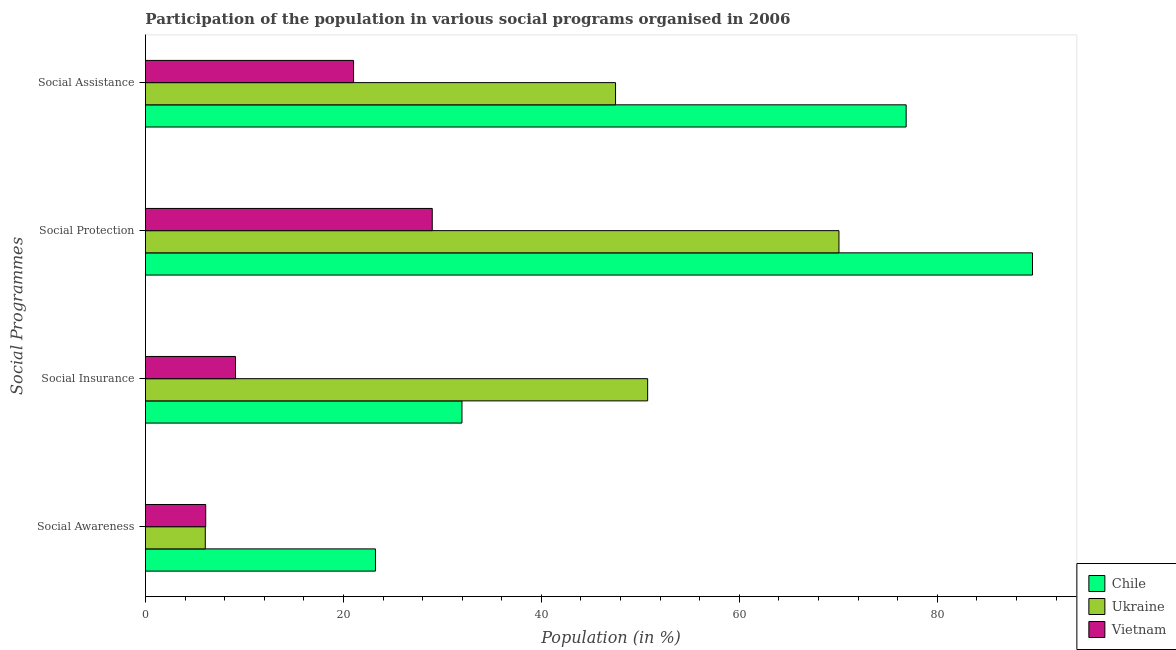How many groups of bars are there?
Provide a short and direct response. 4. What is the label of the 2nd group of bars from the top?
Your answer should be very brief. Social Protection. What is the participation of population in social awareness programs in Vietnam?
Make the answer very short. 6.09. Across all countries, what is the maximum participation of population in social assistance programs?
Give a very brief answer. 76.86. Across all countries, what is the minimum participation of population in social insurance programs?
Your answer should be compact. 9.1. In which country was the participation of population in social protection programs maximum?
Your response must be concise. Chile. In which country was the participation of population in social awareness programs minimum?
Give a very brief answer. Ukraine. What is the total participation of population in social assistance programs in the graph?
Offer a very short reply. 145.38. What is the difference between the participation of population in social insurance programs in Ukraine and that in Vietnam?
Provide a succinct answer. 41.64. What is the difference between the participation of population in social insurance programs in Chile and the participation of population in social assistance programs in Ukraine?
Provide a short and direct response. -15.52. What is the average participation of population in social protection programs per country?
Offer a terse response. 62.89. What is the difference between the participation of population in social assistance programs and participation of population in social insurance programs in Vietnam?
Ensure brevity in your answer.  11.93. What is the ratio of the participation of population in social awareness programs in Chile to that in Ukraine?
Make the answer very short. 3.84. Is the participation of population in social awareness programs in Chile less than that in Ukraine?
Provide a succinct answer. No. What is the difference between the highest and the second highest participation of population in social awareness programs?
Your response must be concise. 17.15. What is the difference between the highest and the lowest participation of population in social protection programs?
Provide a short and direct response. 60.64. Is it the case that in every country, the sum of the participation of population in social protection programs and participation of population in social insurance programs is greater than the sum of participation of population in social assistance programs and participation of population in social awareness programs?
Ensure brevity in your answer.  No. What does the 2nd bar from the top in Social Protection represents?
Keep it short and to the point. Ukraine. What does the 3rd bar from the bottom in Social Assistance represents?
Provide a succinct answer. Vietnam. How many countries are there in the graph?
Your answer should be very brief. 3. What is the difference between two consecutive major ticks on the X-axis?
Provide a short and direct response. 20. How many legend labels are there?
Make the answer very short. 3. What is the title of the graph?
Your answer should be compact. Participation of the population in various social programs organised in 2006. Does "Israel" appear as one of the legend labels in the graph?
Keep it short and to the point. No. What is the label or title of the X-axis?
Ensure brevity in your answer.  Population (in %). What is the label or title of the Y-axis?
Offer a very short reply. Social Programmes. What is the Population (in %) in Chile in Social Awareness?
Provide a succinct answer. 23.24. What is the Population (in %) of Ukraine in Social Awareness?
Offer a very short reply. 6.04. What is the Population (in %) of Vietnam in Social Awareness?
Your answer should be very brief. 6.09. What is the Population (in %) of Chile in Social Insurance?
Your response must be concise. 31.98. What is the Population (in %) of Ukraine in Social Insurance?
Your answer should be compact. 50.74. What is the Population (in %) in Vietnam in Social Insurance?
Keep it short and to the point. 9.1. What is the Population (in %) of Chile in Social Protection?
Provide a succinct answer. 89.62. What is the Population (in %) of Ukraine in Social Protection?
Offer a very short reply. 70.07. What is the Population (in %) of Vietnam in Social Protection?
Give a very brief answer. 28.98. What is the Population (in %) of Chile in Social Assistance?
Provide a short and direct response. 76.86. What is the Population (in %) of Ukraine in Social Assistance?
Your answer should be compact. 47.5. What is the Population (in %) in Vietnam in Social Assistance?
Provide a succinct answer. 21.03. Across all Social Programmes, what is the maximum Population (in %) of Chile?
Provide a succinct answer. 89.62. Across all Social Programmes, what is the maximum Population (in %) of Ukraine?
Offer a very short reply. 70.07. Across all Social Programmes, what is the maximum Population (in %) of Vietnam?
Ensure brevity in your answer.  28.98. Across all Social Programmes, what is the minimum Population (in %) of Chile?
Your answer should be very brief. 23.24. Across all Social Programmes, what is the minimum Population (in %) of Ukraine?
Your response must be concise. 6.04. Across all Social Programmes, what is the minimum Population (in %) of Vietnam?
Offer a very short reply. 6.09. What is the total Population (in %) of Chile in the graph?
Make the answer very short. 221.69. What is the total Population (in %) of Ukraine in the graph?
Offer a very short reply. 174.35. What is the total Population (in %) in Vietnam in the graph?
Provide a short and direct response. 65.19. What is the difference between the Population (in %) of Chile in Social Awareness and that in Social Insurance?
Offer a very short reply. -8.74. What is the difference between the Population (in %) of Ukraine in Social Awareness and that in Social Insurance?
Give a very brief answer. -44.7. What is the difference between the Population (in %) of Vietnam in Social Awareness and that in Social Insurance?
Ensure brevity in your answer.  -3.01. What is the difference between the Population (in %) of Chile in Social Awareness and that in Social Protection?
Offer a terse response. -66.38. What is the difference between the Population (in %) in Ukraine in Social Awareness and that in Social Protection?
Your response must be concise. -64.02. What is the difference between the Population (in %) in Vietnam in Social Awareness and that in Social Protection?
Keep it short and to the point. -22.89. What is the difference between the Population (in %) in Chile in Social Awareness and that in Social Assistance?
Your answer should be compact. -53.62. What is the difference between the Population (in %) in Ukraine in Social Awareness and that in Social Assistance?
Keep it short and to the point. -41.45. What is the difference between the Population (in %) of Vietnam in Social Awareness and that in Social Assistance?
Provide a short and direct response. -14.94. What is the difference between the Population (in %) of Chile in Social Insurance and that in Social Protection?
Ensure brevity in your answer.  -57.64. What is the difference between the Population (in %) of Ukraine in Social Insurance and that in Social Protection?
Offer a very short reply. -19.33. What is the difference between the Population (in %) of Vietnam in Social Insurance and that in Social Protection?
Offer a very short reply. -19.88. What is the difference between the Population (in %) of Chile in Social Insurance and that in Social Assistance?
Your answer should be very brief. -44.88. What is the difference between the Population (in %) of Ukraine in Social Insurance and that in Social Assistance?
Make the answer very short. 3.24. What is the difference between the Population (in %) in Vietnam in Social Insurance and that in Social Assistance?
Give a very brief answer. -11.93. What is the difference between the Population (in %) of Chile in Social Protection and that in Social Assistance?
Offer a terse response. 12.76. What is the difference between the Population (in %) in Ukraine in Social Protection and that in Social Assistance?
Your answer should be very brief. 22.57. What is the difference between the Population (in %) of Vietnam in Social Protection and that in Social Assistance?
Provide a short and direct response. 7.95. What is the difference between the Population (in %) in Chile in Social Awareness and the Population (in %) in Ukraine in Social Insurance?
Provide a short and direct response. -27.5. What is the difference between the Population (in %) of Chile in Social Awareness and the Population (in %) of Vietnam in Social Insurance?
Your response must be concise. 14.14. What is the difference between the Population (in %) of Ukraine in Social Awareness and the Population (in %) of Vietnam in Social Insurance?
Offer a terse response. -3.06. What is the difference between the Population (in %) of Chile in Social Awareness and the Population (in %) of Ukraine in Social Protection?
Make the answer very short. -46.83. What is the difference between the Population (in %) in Chile in Social Awareness and the Population (in %) in Vietnam in Social Protection?
Offer a very short reply. -5.74. What is the difference between the Population (in %) in Ukraine in Social Awareness and the Population (in %) in Vietnam in Social Protection?
Give a very brief answer. -22.93. What is the difference between the Population (in %) of Chile in Social Awareness and the Population (in %) of Ukraine in Social Assistance?
Offer a very short reply. -24.26. What is the difference between the Population (in %) in Chile in Social Awareness and the Population (in %) in Vietnam in Social Assistance?
Your answer should be very brief. 2.21. What is the difference between the Population (in %) of Ukraine in Social Awareness and the Population (in %) of Vietnam in Social Assistance?
Your answer should be compact. -14.98. What is the difference between the Population (in %) in Chile in Social Insurance and the Population (in %) in Ukraine in Social Protection?
Make the answer very short. -38.09. What is the difference between the Population (in %) in Chile in Social Insurance and the Population (in %) in Vietnam in Social Protection?
Provide a succinct answer. 3. What is the difference between the Population (in %) in Ukraine in Social Insurance and the Population (in %) in Vietnam in Social Protection?
Your answer should be compact. 21.76. What is the difference between the Population (in %) in Chile in Social Insurance and the Population (in %) in Ukraine in Social Assistance?
Make the answer very short. -15.52. What is the difference between the Population (in %) in Chile in Social Insurance and the Population (in %) in Vietnam in Social Assistance?
Provide a succinct answer. 10.95. What is the difference between the Population (in %) in Ukraine in Social Insurance and the Population (in %) in Vietnam in Social Assistance?
Your answer should be compact. 29.71. What is the difference between the Population (in %) of Chile in Social Protection and the Population (in %) of Ukraine in Social Assistance?
Your answer should be very brief. 42.13. What is the difference between the Population (in %) in Chile in Social Protection and the Population (in %) in Vietnam in Social Assistance?
Provide a succinct answer. 68.59. What is the difference between the Population (in %) in Ukraine in Social Protection and the Population (in %) in Vietnam in Social Assistance?
Ensure brevity in your answer.  49.04. What is the average Population (in %) of Chile per Social Programmes?
Offer a very short reply. 55.42. What is the average Population (in %) in Ukraine per Social Programmes?
Your answer should be very brief. 43.59. What is the average Population (in %) of Vietnam per Social Programmes?
Ensure brevity in your answer.  16.3. What is the difference between the Population (in %) of Chile and Population (in %) of Ukraine in Social Awareness?
Provide a succinct answer. 17.19. What is the difference between the Population (in %) in Chile and Population (in %) in Vietnam in Social Awareness?
Ensure brevity in your answer.  17.15. What is the difference between the Population (in %) in Ukraine and Population (in %) in Vietnam in Social Awareness?
Provide a short and direct response. -0.04. What is the difference between the Population (in %) in Chile and Population (in %) in Ukraine in Social Insurance?
Make the answer very short. -18.76. What is the difference between the Population (in %) in Chile and Population (in %) in Vietnam in Social Insurance?
Provide a short and direct response. 22.88. What is the difference between the Population (in %) in Ukraine and Population (in %) in Vietnam in Social Insurance?
Your response must be concise. 41.64. What is the difference between the Population (in %) in Chile and Population (in %) in Ukraine in Social Protection?
Make the answer very short. 19.55. What is the difference between the Population (in %) in Chile and Population (in %) in Vietnam in Social Protection?
Provide a succinct answer. 60.64. What is the difference between the Population (in %) in Ukraine and Population (in %) in Vietnam in Social Protection?
Provide a short and direct response. 41.09. What is the difference between the Population (in %) of Chile and Population (in %) of Ukraine in Social Assistance?
Offer a terse response. 29.36. What is the difference between the Population (in %) of Chile and Population (in %) of Vietnam in Social Assistance?
Offer a terse response. 55.83. What is the difference between the Population (in %) in Ukraine and Population (in %) in Vietnam in Social Assistance?
Give a very brief answer. 26.47. What is the ratio of the Population (in %) in Chile in Social Awareness to that in Social Insurance?
Make the answer very short. 0.73. What is the ratio of the Population (in %) of Ukraine in Social Awareness to that in Social Insurance?
Your response must be concise. 0.12. What is the ratio of the Population (in %) of Vietnam in Social Awareness to that in Social Insurance?
Your answer should be compact. 0.67. What is the ratio of the Population (in %) of Chile in Social Awareness to that in Social Protection?
Your answer should be very brief. 0.26. What is the ratio of the Population (in %) of Ukraine in Social Awareness to that in Social Protection?
Your answer should be very brief. 0.09. What is the ratio of the Population (in %) of Vietnam in Social Awareness to that in Social Protection?
Your answer should be compact. 0.21. What is the ratio of the Population (in %) of Chile in Social Awareness to that in Social Assistance?
Provide a short and direct response. 0.3. What is the ratio of the Population (in %) in Ukraine in Social Awareness to that in Social Assistance?
Your answer should be compact. 0.13. What is the ratio of the Population (in %) in Vietnam in Social Awareness to that in Social Assistance?
Ensure brevity in your answer.  0.29. What is the ratio of the Population (in %) in Chile in Social Insurance to that in Social Protection?
Ensure brevity in your answer.  0.36. What is the ratio of the Population (in %) of Ukraine in Social Insurance to that in Social Protection?
Ensure brevity in your answer.  0.72. What is the ratio of the Population (in %) in Vietnam in Social Insurance to that in Social Protection?
Give a very brief answer. 0.31. What is the ratio of the Population (in %) of Chile in Social Insurance to that in Social Assistance?
Give a very brief answer. 0.42. What is the ratio of the Population (in %) of Ukraine in Social Insurance to that in Social Assistance?
Provide a succinct answer. 1.07. What is the ratio of the Population (in %) of Vietnam in Social Insurance to that in Social Assistance?
Offer a very short reply. 0.43. What is the ratio of the Population (in %) of Chile in Social Protection to that in Social Assistance?
Make the answer very short. 1.17. What is the ratio of the Population (in %) of Ukraine in Social Protection to that in Social Assistance?
Keep it short and to the point. 1.48. What is the ratio of the Population (in %) of Vietnam in Social Protection to that in Social Assistance?
Your answer should be very brief. 1.38. What is the difference between the highest and the second highest Population (in %) in Chile?
Your answer should be compact. 12.76. What is the difference between the highest and the second highest Population (in %) in Ukraine?
Provide a short and direct response. 19.33. What is the difference between the highest and the second highest Population (in %) in Vietnam?
Your answer should be very brief. 7.95. What is the difference between the highest and the lowest Population (in %) of Chile?
Make the answer very short. 66.38. What is the difference between the highest and the lowest Population (in %) of Ukraine?
Provide a succinct answer. 64.02. What is the difference between the highest and the lowest Population (in %) in Vietnam?
Provide a short and direct response. 22.89. 